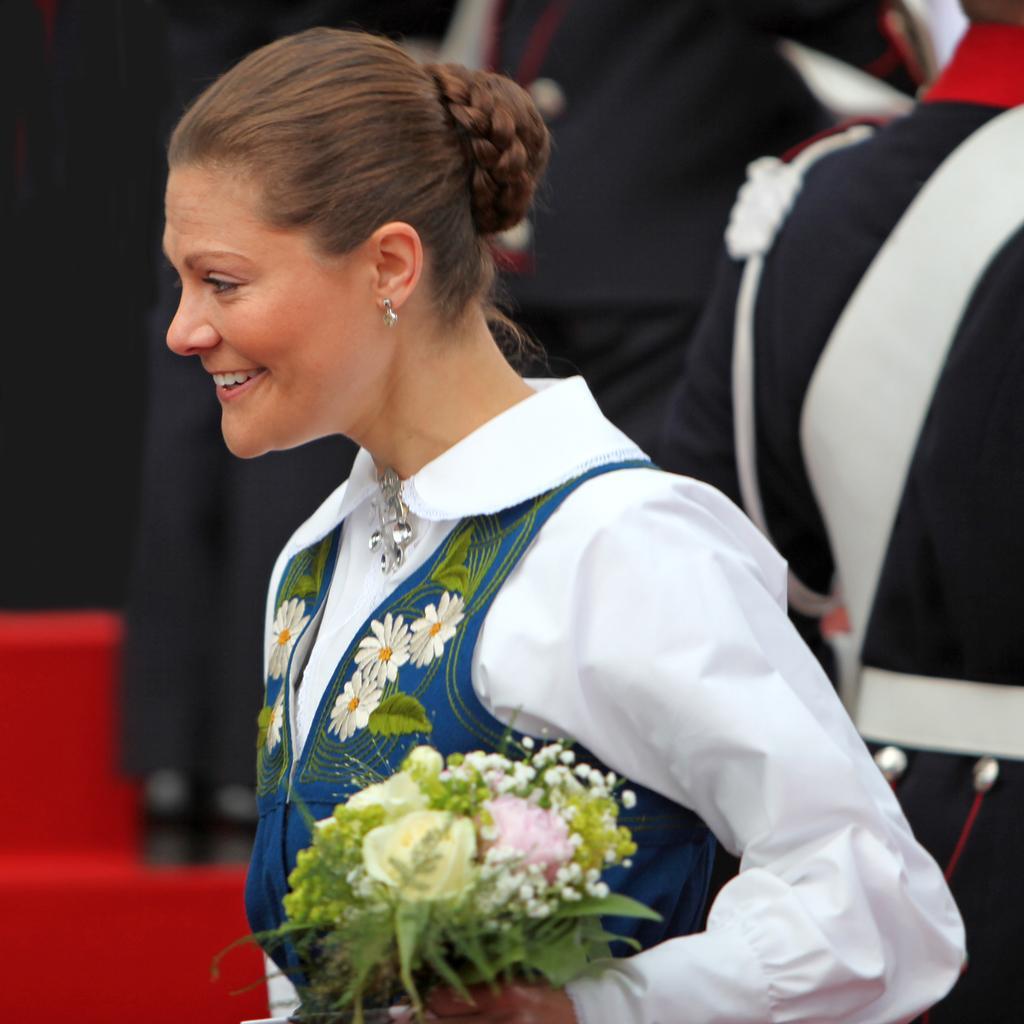In one or two sentences, can you explain what this image depicts? We can see a woman is standing and holding a flower bouquet in her hand and she is smiling. In the background there are few persons. on the left side we can see a person is standing on the carpet on the steps. 